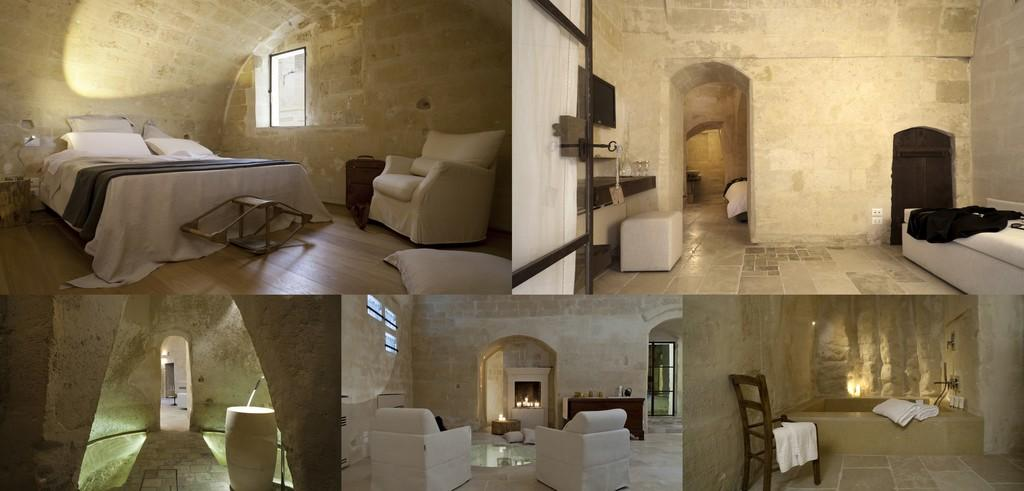What type of furniture is present in the image? There are couches, beds, and a chair in the image. What items are used for comfort or support in the image? There are pillows and towels in the image. What can be seen on the walls in the image? There is a screen in the image. What objects are placed on tables in the image? There are objects on tables in the image. What allows natural light to enter the room in the image? There are windows in the image. What type of branch is growing through the window in the image? There is no branch growing through the window in the image; it only shows windows and no vegetation. What is the source of smoke in the image? There is no smoke present in the image. 